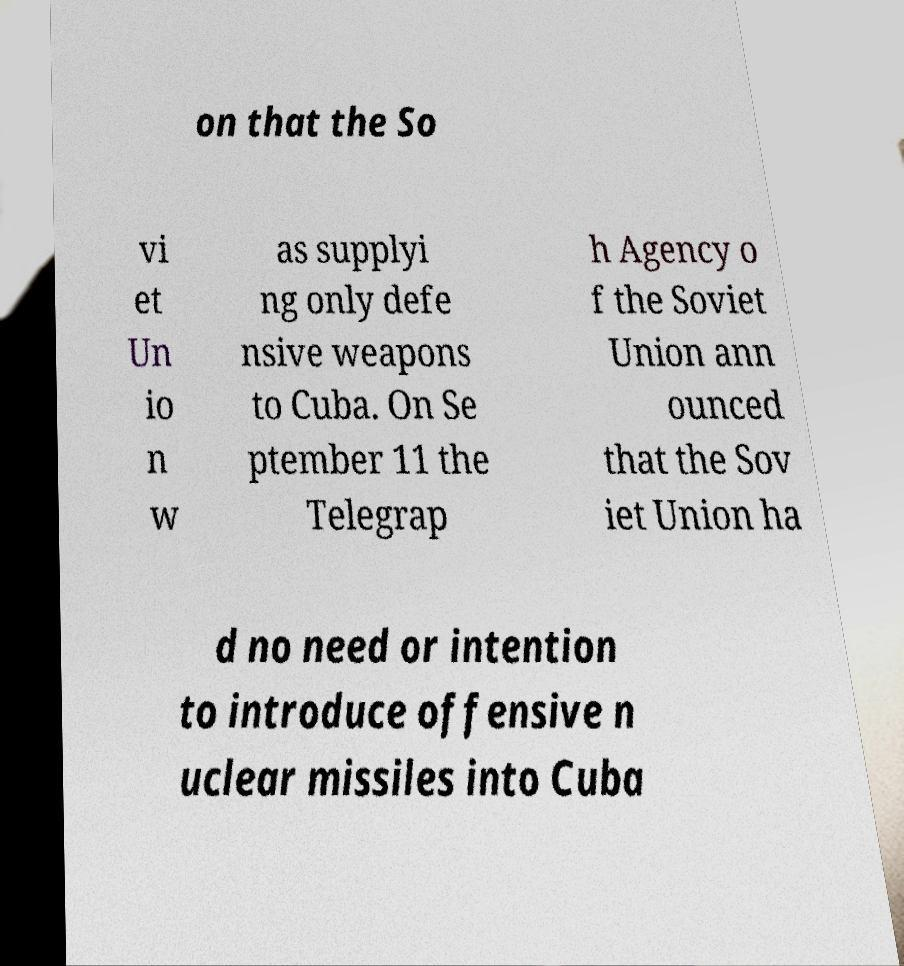Can you accurately transcribe the text from the provided image for me? on that the So vi et Un io n w as supplyi ng only defe nsive weapons to Cuba. On Se ptember 11 the Telegrap h Agency o f the Soviet Union ann ounced that the Sov iet Union ha d no need or intention to introduce offensive n uclear missiles into Cuba 